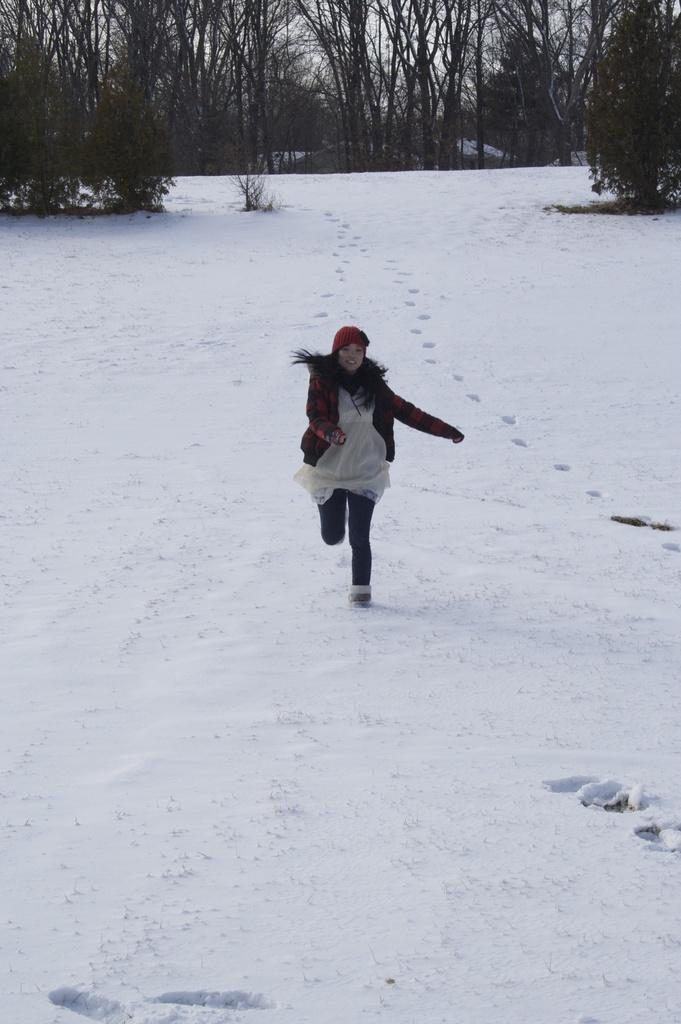Who is the main subject in the image? There is a girl in the center of the image. What is the girl standing on? The girl is standing on a snow floor. What can be seen in the background of the image? There are trees at the top side of the image. What type of body of water can be seen in the image? There is no body of water present in the image; it features a girl standing on a snow floor with trees in the background. 